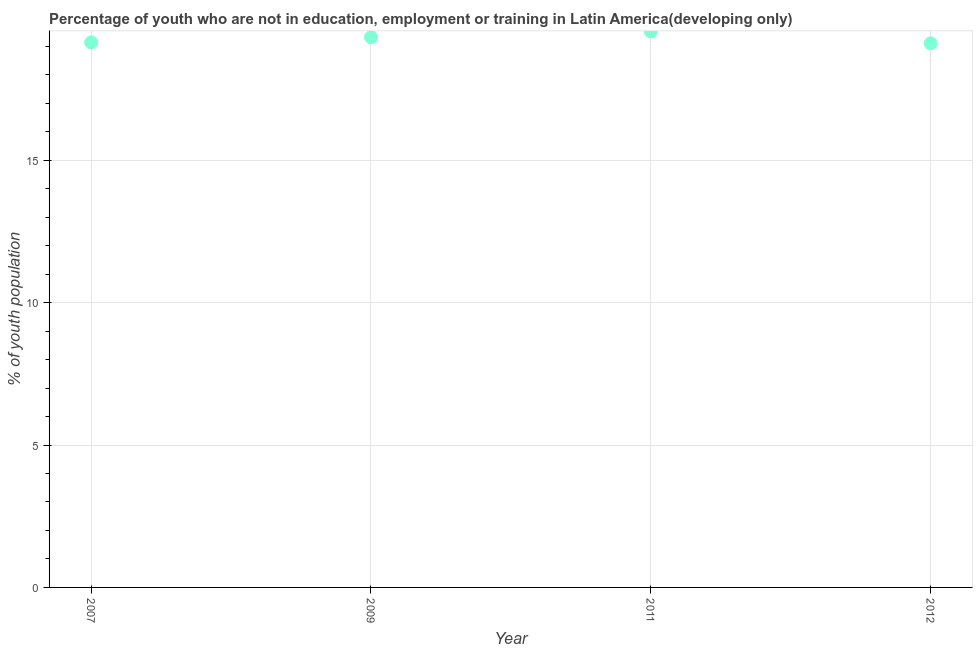What is the unemployed youth population in 2012?
Make the answer very short. 19.1. Across all years, what is the maximum unemployed youth population?
Provide a succinct answer. 19.52. Across all years, what is the minimum unemployed youth population?
Ensure brevity in your answer.  19.1. In which year was the unemployed youth population maximum?
Your answer should be compact. 2011. In which year was the unemployed youth population minimum?
Make the answer very short. 2012. What is the sum of the unemployed youth population?
Your answer should be very brief. 77.08. What is the difference between the unemployed youth population in 2011 and 2012?
Your answer should be very brief. 0.42. What is the average unemployed youth population per year?
Your answer should be very brief. 19.27. What is the median unemployed youth population?
Your response must be concise. 19.23. What is the ratio of the unemployed youth population in 2011 to that in 2012?
Provide a short and direct response. 1.02. Is the unemployed youth population in 2007 less than that in 2009?
Give a very brief answer. Yes. What is the difference between the highest and the second highest unemployed youth population?
Ensure brevity in your answer.  0.2. What is the difference between the highest and the lowest unemployed youth population?
Offer a very short reply. 0.42. How many dotlines are there?
Your answer should be very brief. 1. How many years are there in the graph?
Ensure brevity in your answer.  4. Does the graph contain any zero values?
Give a very brief answer. No. Does the graph contain grids?
Your answer should be compact. Yes. What is the title of the graph?
Ensure brevity in your answer.  Percentage of youth who are not in education, employment or training in Latin America(developing only). What is the label or title of the Y-axis?
Give a very brief answer. % of youth population. What is the % of youth population in 2007?
Offer a terse response. 19.14. What is the % of youth population in 2009?
Provide a succinct answer. 19.32. What is the % of youth population in 2011?
Your answer should be compact. 19.52. What is the % of youth population in 2012?
Your answer should be very brief. 19.1. What is the difference between the % of youth population in 2007 and 2009?
Give a very brief answer. -0.18. What is the difference between the % of youth population in 2007 and 2011?
Provide a short and direct response. -0.39. What is the difference between the % of youth population in 2007 and 2012?
Ensure brevity in your answer.  0.03. What is the difference between the % of youth population in 2009 and 2011?
Give a very brief answer. -0.2. What is the difference between the % of youth population in 2009 and 2012?
Your response must be concise. 0.21. What is the difference between the % of youth population in 2011 and 2012?
Give a very brief answer. 0.42. What is the ratio of the % of youth population in 2007 to that in 2011?
Your answer should be very brief. 0.98. What is the ratio of the % of youth population in 2009 to that in 2011?
Give a very brief answer. 0.99. 